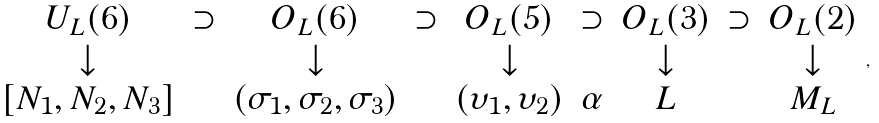Convert formula to latex. <formula><loc_0><loc_0><loc_500><loc_500>\begin{array} { c c c c c c c c c } U _ { L } ( 6 ) & \supset & O _ { L } ( 6 ) & \supset & O _ { L } ( 5 ) & \supset & O _ { L } ( 3 ) & \supset & O _ { L } ( 2 ) \\ \downarrow & & \downarrow & & \downarrow & & \downarrow & & \downarrow \\ { [ N _ { 1 } , N _ { 2 } , N _ { 3 } ] } & & ( \sigma _ { 1 } , \sigma _ { 2 } , \sigma _ { 3 } ) & & ( \upsilon _ { 1 } , \upsilon _ { 2 } ) & \alpha & L & & M _ { L } \end{array} ,</formula> 